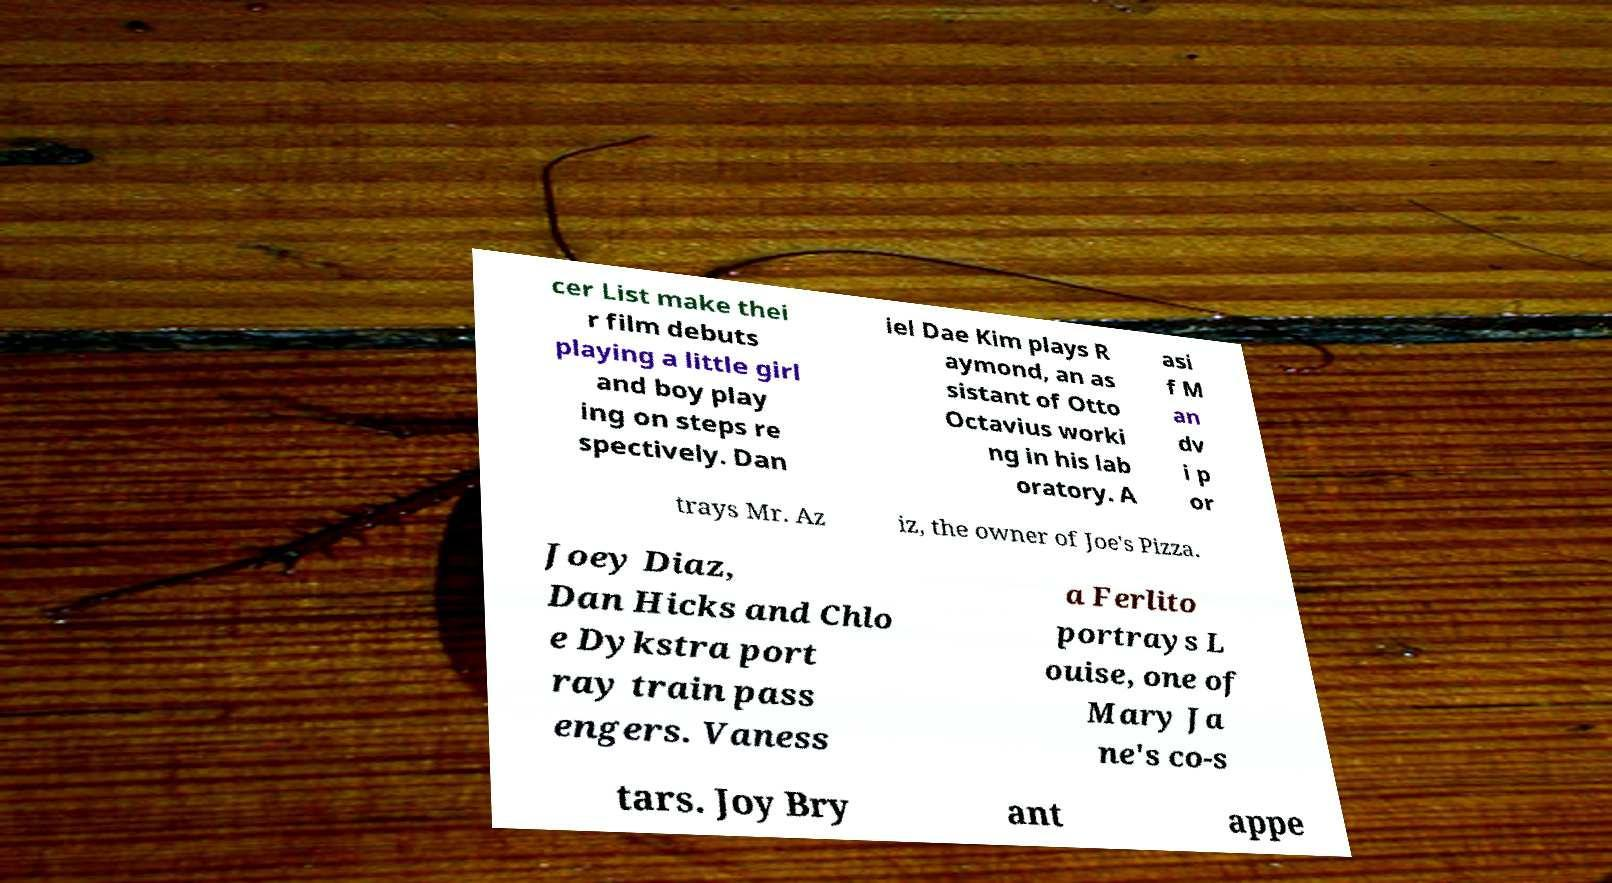Could you assist in decoding the text presented in this image and type it out clearly? cer List make thei r film debuts playing a little girl and boy play ing on steps re spectively. Dan iel Dae Kim plays R aymond, an as sistant of Otto Octavius worki ng in his lab oratory. A asi f M an dv i p or trays Mr. Az iz, the owner of Joe's Pizza. Joey Diaz, Dan Hicks and Chlo e Dykstra port ray train pass engers. Vaness a Ferlito portrays L ouise, one of Mary Ja ne's co-s tars. Joy Bry ant appe 